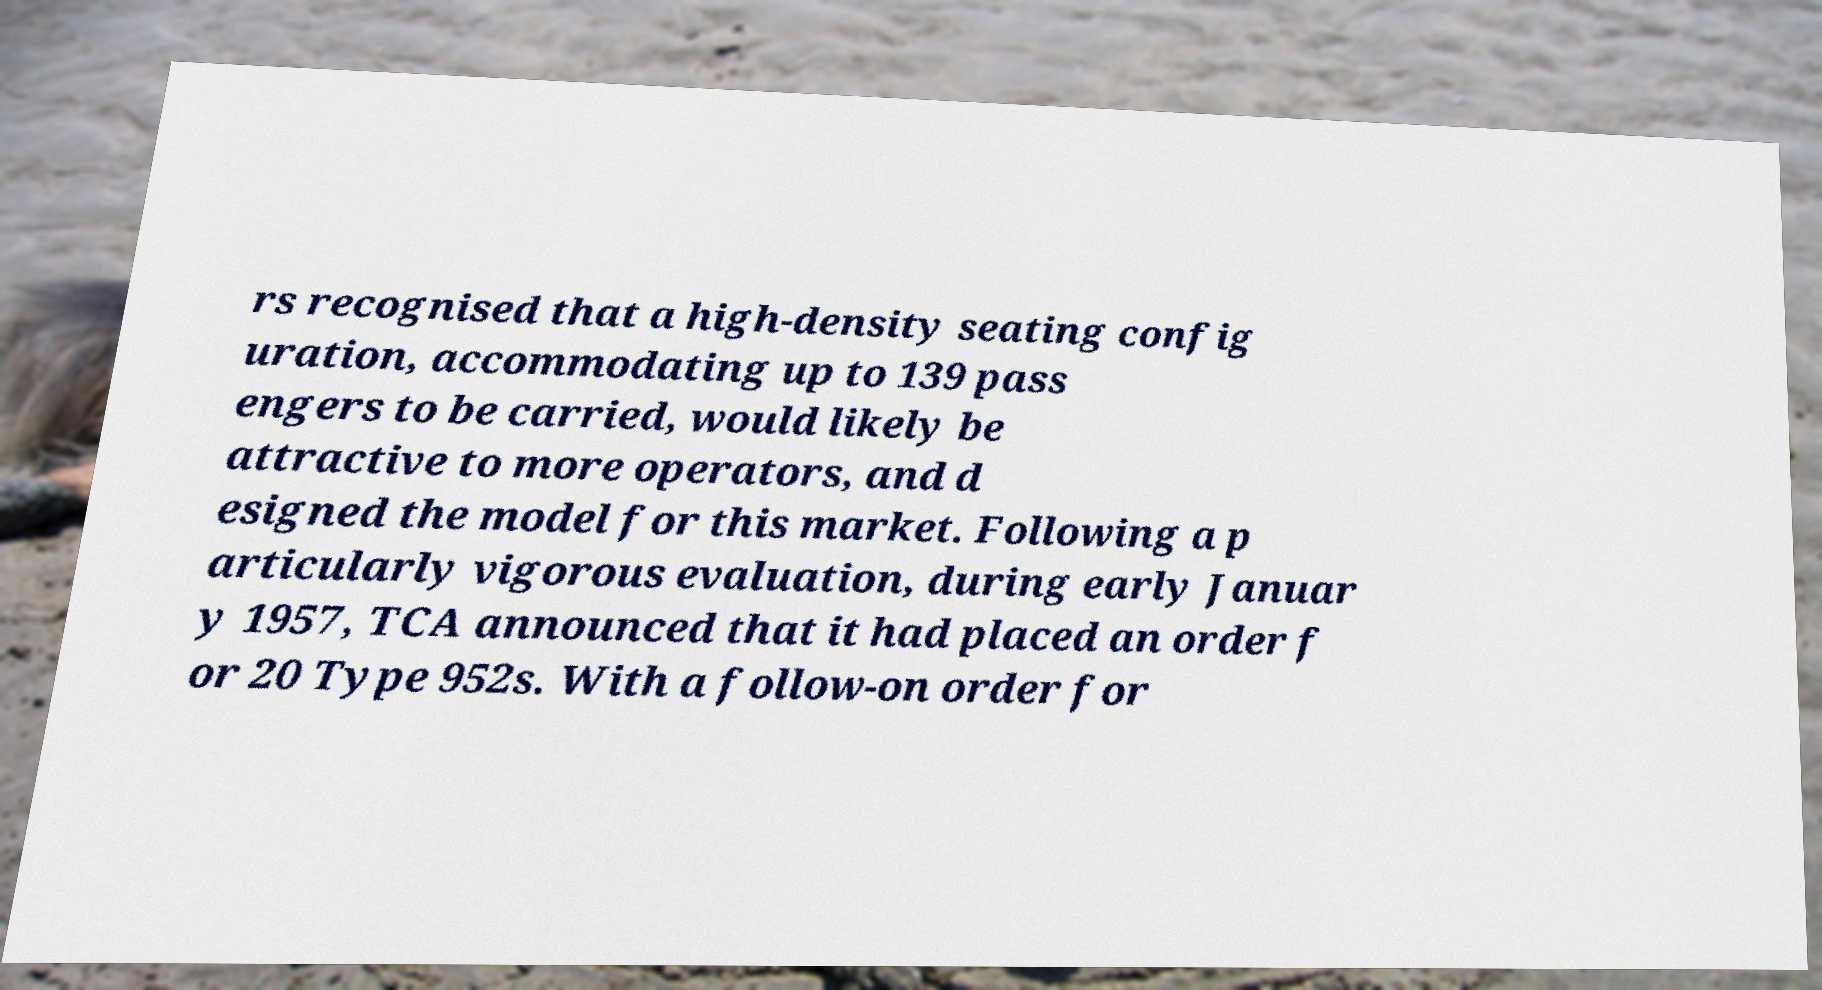Can you read and provide the text displayed in the image?This photo seems to have some interesting text. Can you extract and type it out for me? rs recognised that a high-density seating config uration, accommodating up to 139 pass engers to be carried, would likely be attractive to more operators, and d esigned the model for this market. Following a p articularly vigorous evaluation, during early Januar y 1957, TCA announced that it had placed an order f or 20 Type 952s. With a follow-on order for 